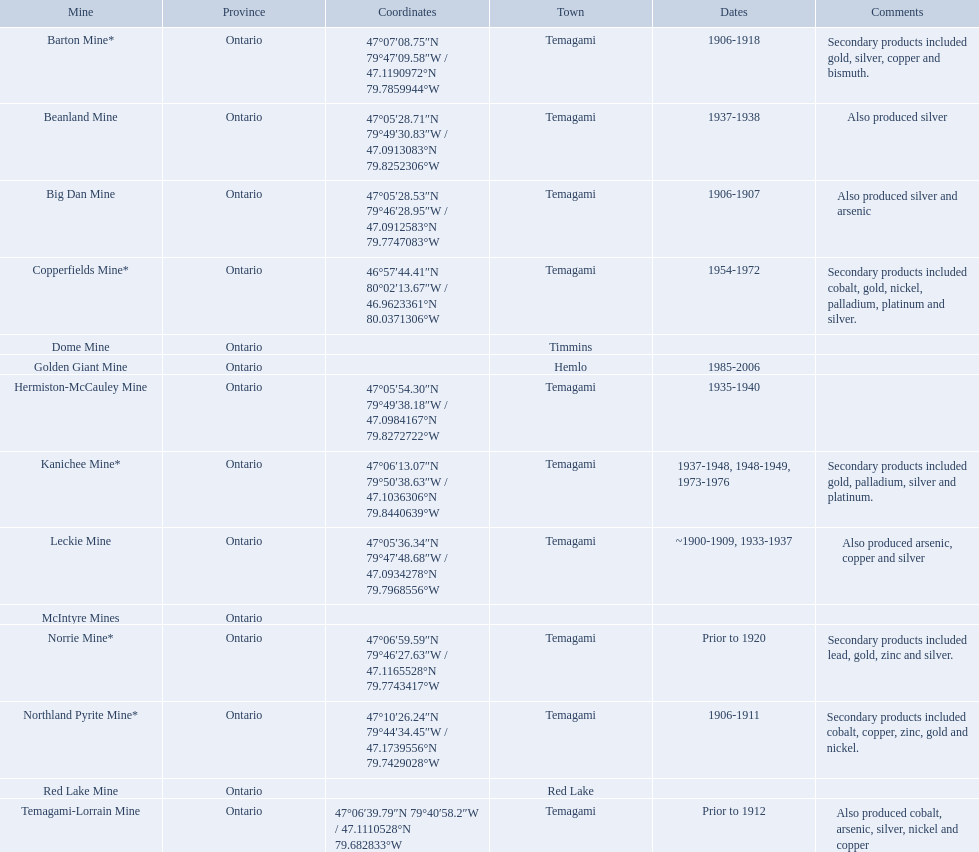What are all the mines with dates listed? Barton Mine*, Beanland Mine, Big Dan Mine, Copperfields Mine*, Golden Giant Mine, Hermiston-McCauley Mine, Kanichee Mine*, Leckie Mine, Norrie Mine*, Northland Pyrite Mine*, Temagami-Lorrain Mine. Would you mind parsing the complete table? {'header': ['Mine', 'Province', 'Coordinates', 'Town', 'Dates', 'Comments'], 'rows': [['Barton Mine*', 'Ontario', '47°07′08.75″N 79°47′09.58″W\ufeff / \ufeff47.1190972°N 79.7859944°W', 'Temagami', '1906-1918', 'Secondary products included gold, silver, copper and bismuth.'], ['Beanland Mine', 'Ontario', '47°05′28.71″N 79°49′30.83″W\ufeff / \ufeff47.0913083°N 79.8252306°W', 'Temagami', '1937-1938', 'Also produced silver'], ['Big Dan Mine', 'Ontario', '47°05′28.53″N 79°46′28.95″W\ufeff / \ufeff47.0912583°N 79.7747083°W', 'Temagami', '1906-1907', 'Also produced silver and arsenic'], ['Copperfields Mine*', 'Ontario', '46°57′44.41″N 80°02′13.67″W\ufeff / \ufeff46.9623361°N 80.0371306°W', 'Temagami', '1954-1972', 'Secondary products included cobalt, gold, nickel, palladium, platinum and silver.'], ['Dome Mine', 'Ontario', '', 'Timmins', '', ''], ['Golden Giant Mine', 'Ontario', '', 'Hemlo', '1985-2006', ''], ['Hermiston-McCauley Mine', 'Ontario', '47°05′54.30″N 79°49′38.18″W\ufeff / \ufeff47.0984167°N 79.8272722°W', 'Temagami', '1935-1940', ''], ['Kanichee Mine*', 'Ontario', '47°06′13.07″N 79°50′38.63″W\ufeff / \ufeff47.1036306°N 79.8440639°W', 'Temagami', '1937-1948, 1948-1949, 1973-1976', 'Secondary products included gold, palladium, silver and platinum.'], ['Leckie Mine', 'Ontario', '47°05′36.34″N 79°47′48.68″W\ufeff / \ufeff47.0934278°N 79.7968556°W', 'Temagami', '~1900-1909, 1933-1937', 'Also produced arsenic, copper and silver'], ['McIntyre Mines', 'Ontario', '', '', '', ''], ['Norrie Mine*', 'Ontario', '47°06′59.59″N 79°46′27.63″W\ufeff / \ufeff47.1165528°N 79.7743417°W', 'Temagami', 'Prior to 1920', 'Secondary products included lead, gold, zinc and silver.'], ['Northland Pyrite Mine*', 'Ontario', '47°10′26.24″N 79°44′34.45″W\ufeff / \ufeff47.1739556°N 79.7429028°W', 'Temagami', '1906-1911', 'Secondary products included cobalt, copper, zinc, gold and nickel.'], ['Red Lake Mine', 'Ontario', '', 'Red Lake', '', ''], ['Temagami-Lorrain Mine', 'Ontario', '47°06′39.79″N 79°40′58.2″W\ufeff / \ufeff47.1110528°N 79.682833°W', 'Temagami', 'Prior to 1912', 'Also produced cobalt, arsenic, silver, nickel and copper']]} Which of those dates include the year that the mine was closed? 1906-1918, 1937-1938, 1906-1907, 1954-1972, 1985-2006, 1935-1940, 1937-1948, 1948-1949, 1973-1976, ~1900-1909, 1933-1937, 1906-1911. Which of those mines were opened the longest? Golden Giant Mine. During which dates was the golden giant mine active? 1985-2006. During which dates was the beanland mine active? 1937-1938. Among these mines, which had a longer period of activity? Golden Giant Mine. In which years was the golden giant mine active? 1985-2006. In which years was the beanland mine active? 1937-1938. Which of these two mines had a longer duration of activity? Golden Giant Mine. What are all the mines with known dates? Barton Mine*, Beanland Mine, Big Dan Mine, Copperfields Mine*, Golden Giant Mine, Hermiston-McCauley Mine, Kanichee Mine*, Leckie Mine, Norrie Mine*, Northland Pyrite Mine*, Temagami-Lorrain Mine. Which of those dates consist of the year the mine was terminated? 1906-1918, 1937-1938, 1906-1907, 1954-1972, 1985-2006, 1935-1940, 1937-1948, 1948-1949, 1973-1976, ~1900-1909, 1933-1937, 1906-1911. Which of those mines were functioning the longest? Golden Giant Mine. During which time periods was the golden giant mine operational? 1985-2006. When was the beanland mine in operation? 1937-1938. Between the two, which had a longer operational duration? Golden Giant Mine. During which years was the golden giant mine operational? 1985-2006. For what period was the beanland mine functioning? 1937-1938. Which mine had a longer operational duration between the two? Golden Giant Mine. In which years did the golden giant mine operate? 1985-2006. When was the beanland mine in operation? 1937-1938. Which one of these mines had a more extended operational period? Golden Giant Mine. 